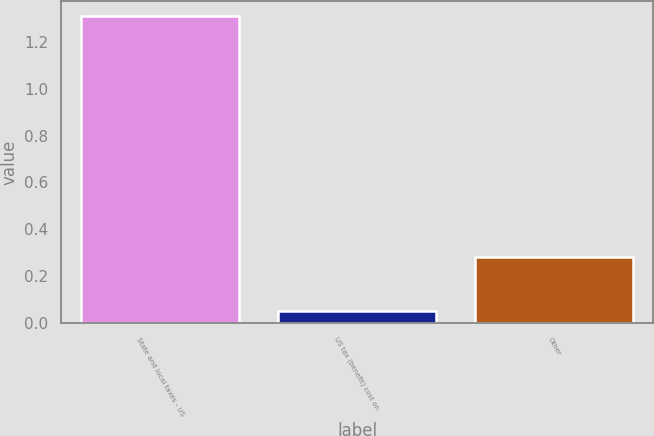Convert chart to OTSL. <chart><loc_0><loc_0><loc_500><loc_500><bar_chart><fcel>State and local taxes - US<fcel>US tax (benefit) cost on<fcel>Other<nl><fcel>1.31<fcel>0.05<fcel>0.28<nl></chart> 